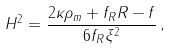Convert formula to latex. <formula><loc_0><loc_0><loc_500><loc_500>H ^ { 2 } = \frac { 2 \kappa \rho _ { m } + f _ { R } R - f } { 6 f _ { R } \xi ^ { 2 } } \, ,</formula> 